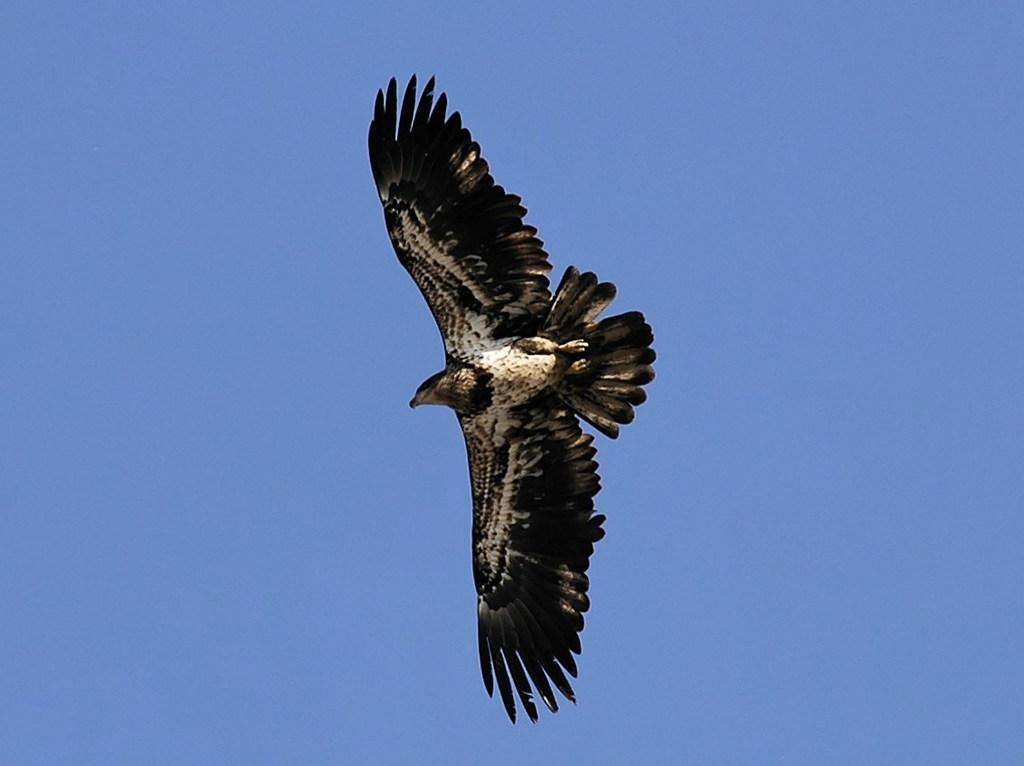Please provide a concise description of this image. In this image I can see a bird which is black, white and brown in color is flying in the air and in the background I can see the sky. 